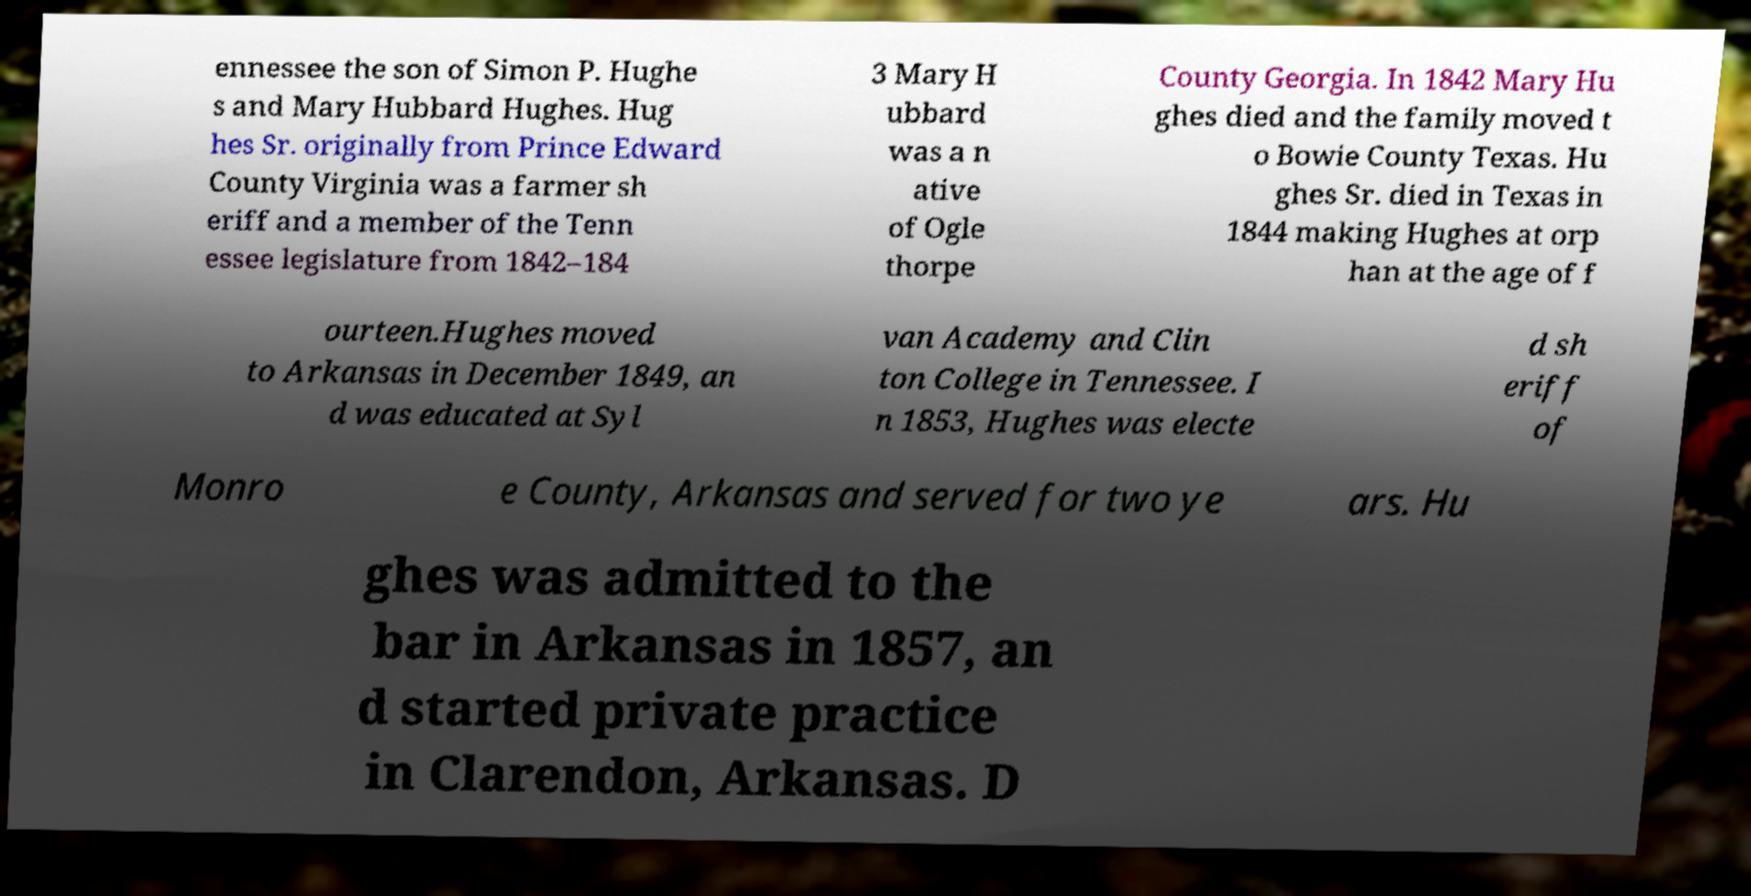Could you extract and type out the text from this image? ennessee the son of Simon P. Hughe s and Mary Hubbard Hughes. Hug hes Sr. originally from Prince Edward County Virginia was a farmer sh eriff and a member of the Tenn essee legislature from 1842–184 3 Mary H ubbard was a n ative of Ogle thorpe County Georgia. In 1842 Mary Hu ghes died and the family moved t o Bowie County Texas. Hu ghes Sr. died in Texas in 1844 making Hughes at orp han at the age of f ourteen.Hughes moved to Arkansas in December 1849, an d was educated at Syl van Academy and Clin ton College in Tennessee. I n 1853, Hughes was electe d sh eriff of Monro e County, Arkansas and served for two ye ars. Hu ghes was admitted to the bar in Arkansas in 1857, an d started private practice in Clarendon, Arkansas. D 